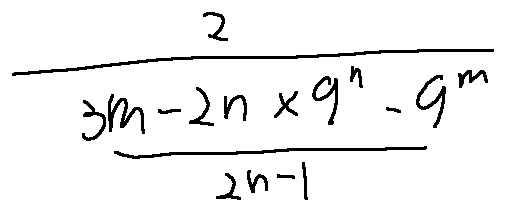<formula> <loc_0><loc_0><loc_500><loc_500>\frac { 2 } { \frac { 3 m - 2 n \times 9 ^ { n } - 9 ^ { m } } { 2 n - 1 } }</formula> 